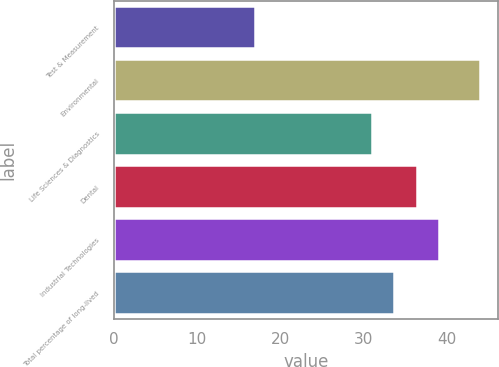<chart> <loc_0><loc_0><loc_500><loc_500><bar_chart><fcel>Test & Measurement<fcel>Environmental<fcel>Life Sciences & Diagnostics<fcel>Dental<fcel>Industrial Technologies<fcel>Total percentage of long-lived<nl><fcel>17<fcel>44<fcel>31<fcel>36.4<fcel>39.1<fcel>33.7<nl></chart> 